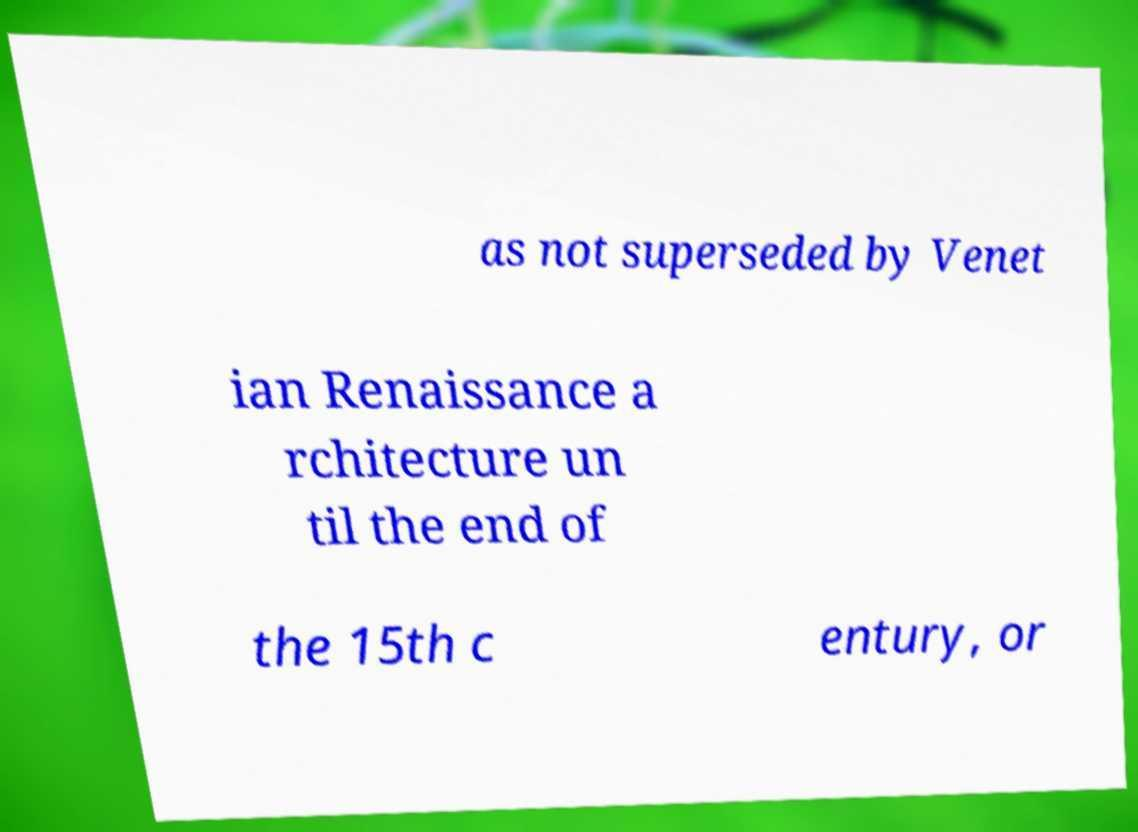Could you extract and type out the text from this image? as not superseded by Venet ian Renaissance a rchitecture un til the end of the 15th c entury, or 